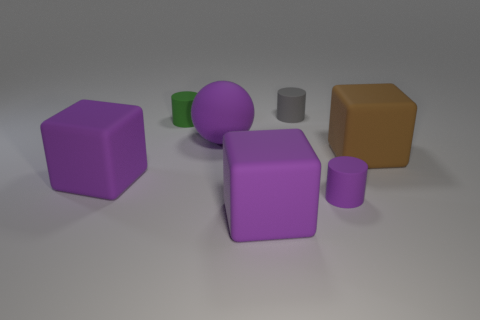What is the shape of the big matte thing to the right of the tiny gray rubber thing?
Make the answer very short. Cube. What number of other objects are the same material as the small gray thing?
Your response must be concise. 6. What is the size of the green cylinder?
Your response must be concise. Small. How many other objects are the same color as the big rubber ball?
Your answer should be compact. 3. There is a tiny cylinder that is both right of the green cylinder and in front of the gray matte cylinder; what is its color?
Provide a short and direct response. Purple. How many small cylinders are there?
Offer a very short reply. 3. Does the green cylinder have the same material as the gray cylinder?
Ensure brevity in your answer.  Yes. What is the shape of the purple rubber object behind the big matte thing that is right of the rubber cylinder that is behind the tiny green rubber cylinder?
Give a very brief answer. Sphere. Do the large thing that is on the right side of the gray rubber thing and the big purple cube that is behind the small purple matte thing have the same material?
Provide a succinct answer. Yes. What is the material of the small purple cylinder?
Your answer should be compact. Rubber. 